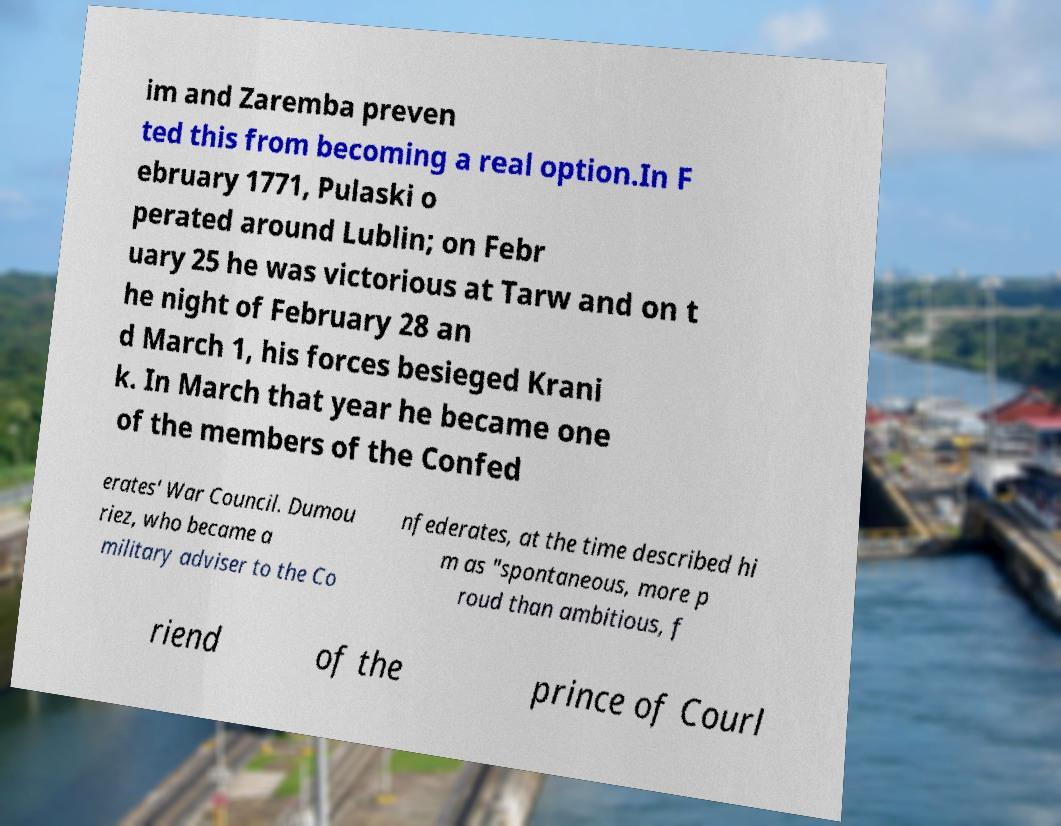What messages or text are displayed in this image? I need them in a readable, typed format. im and Zaremba preven ted this from becoming a real option.In F ebruary 1771, Pulaski o perated around Lublin; on Febr uary 25 he was victorious at Tarw and on t he night of February 28 an d March 1, his forces besieged Krani k. In March that year he became one of the members of the Confed erates' War Council. Dumou riez, who became a military adviser to the Co nfederates, at the time described hi m as "spontaneous, more p roud than ambitious, f riend of the prince of Courl 